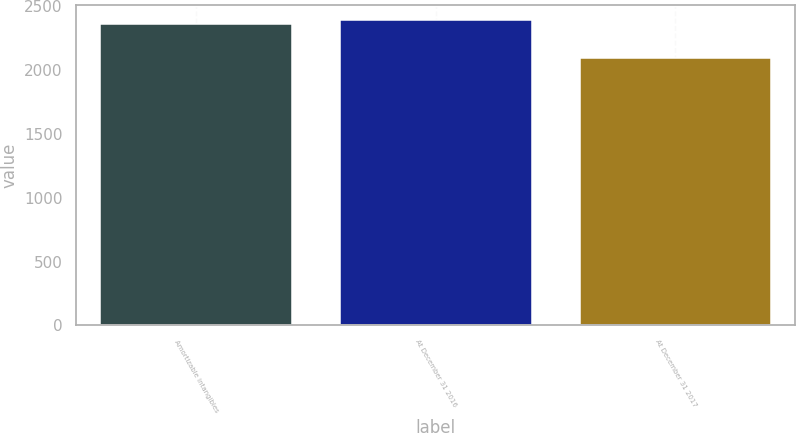Convert chart to OTSL. <chart><loc_0><loc_0><loc_500><loc_500><bar_chart><fcel>Amortizable intangibles<fcel>At December 31 2016<fcel>At December 31 2017<nl><fcel>2361<fcel>2387.9<fcel>2095<nl></chart> 